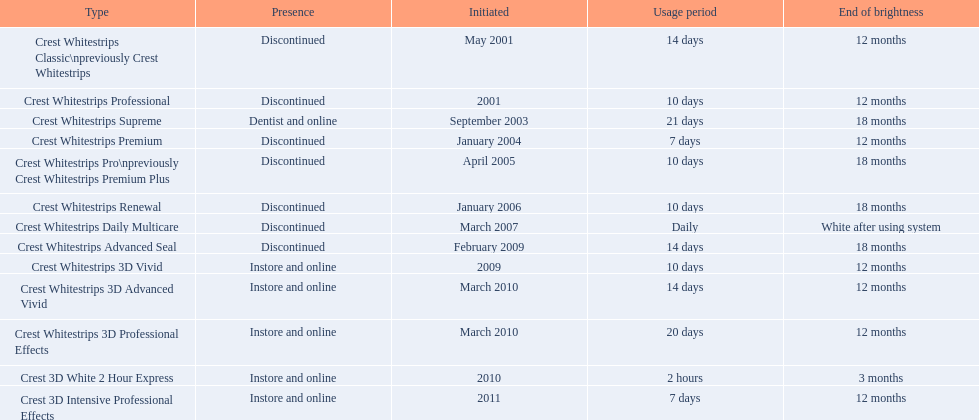When was crest whitestrips 3d advanced vivid introduced? March 2010. What other product was introduced in march 2010? Crest Whitestrips 3D Professional Effects. 